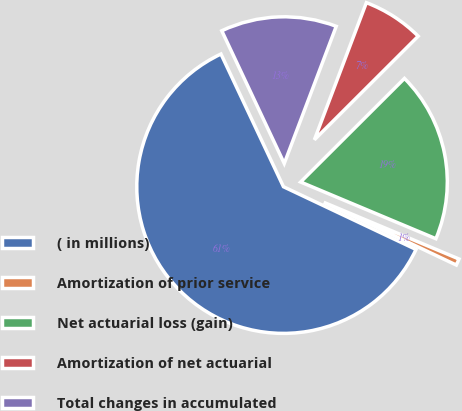Convert chart. <chart><loc_0><loc_0><loc_500><loc_500><pie_chart><fcel>( in millions)<fcel>Amortization of prior service<fcel>Net actuarial loss (gain)<fcel>Amortization of net actuarial<fcel>Total changes in accumulated<nl><fcel>60.96%<fcel>0.72%<fcel>18.8%<fcel>6.75%<fcel>12.77%<nl></chart> 